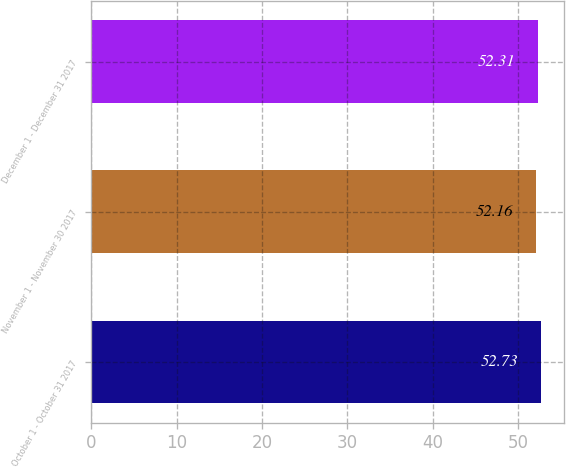Convert chart to OTSL. <chart><loc_0><loc_0><loc_500><loc_500><bar_chart><fcel>October 1 - October 31 2017<fcel>November 1 - November 30 2017<fcel>December 1 - December 31 2017<nl><fcel>52.73<fcel>52.16<fcel>52.31<nl></chart> 